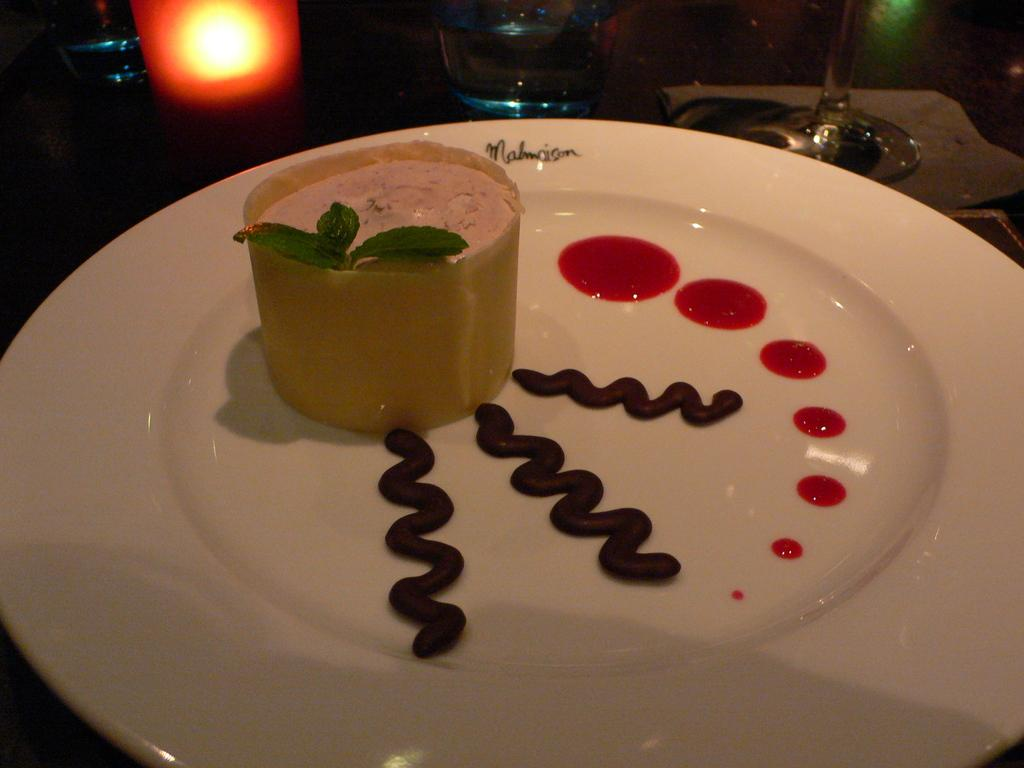What is the main object in the image? There is a candle in the image in the image. What other objects can be seen in the image? There are glasses and a plate with food items visible in the image. Where might these items be placed? The items are likely on a table. In what type of setting is the image likely taken? The image is likely taken in a room. What title does the father hold in the image? There is no person, let alone a father, present in the image. The image only contains a candle, glasses, and a plate with food items. 